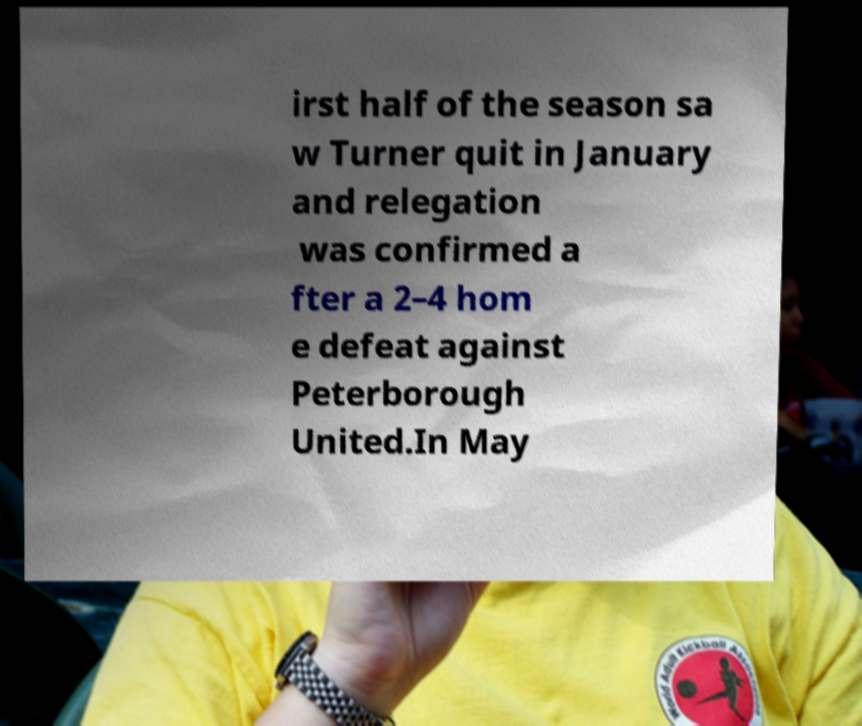Can you read and provide the text displayed in the image?This photo seems to have some interesting text. Can you extract and type it out for me? irst half of the season sa w Turner quit in January and relegation was confirmed a fter a 2–4 hom e defeat against Peterborough United.In May 